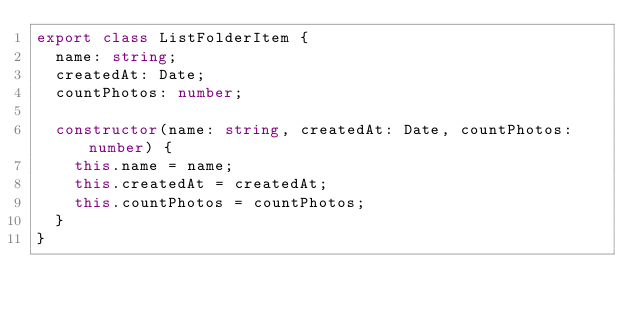<code> <loc_0><loc_0><loc_500><loc_500><_TypeScript_>export class ListFolderItem {
  name: string;
  createdAt: Date;
  countPhotos: number;

  constructor(name: string, createdAt: Date, countPhotos: number) {
    this.name = name;
    this.createdAt = createdAt;
    this.countPhotos = countPhotos;
  }
}
</code> 